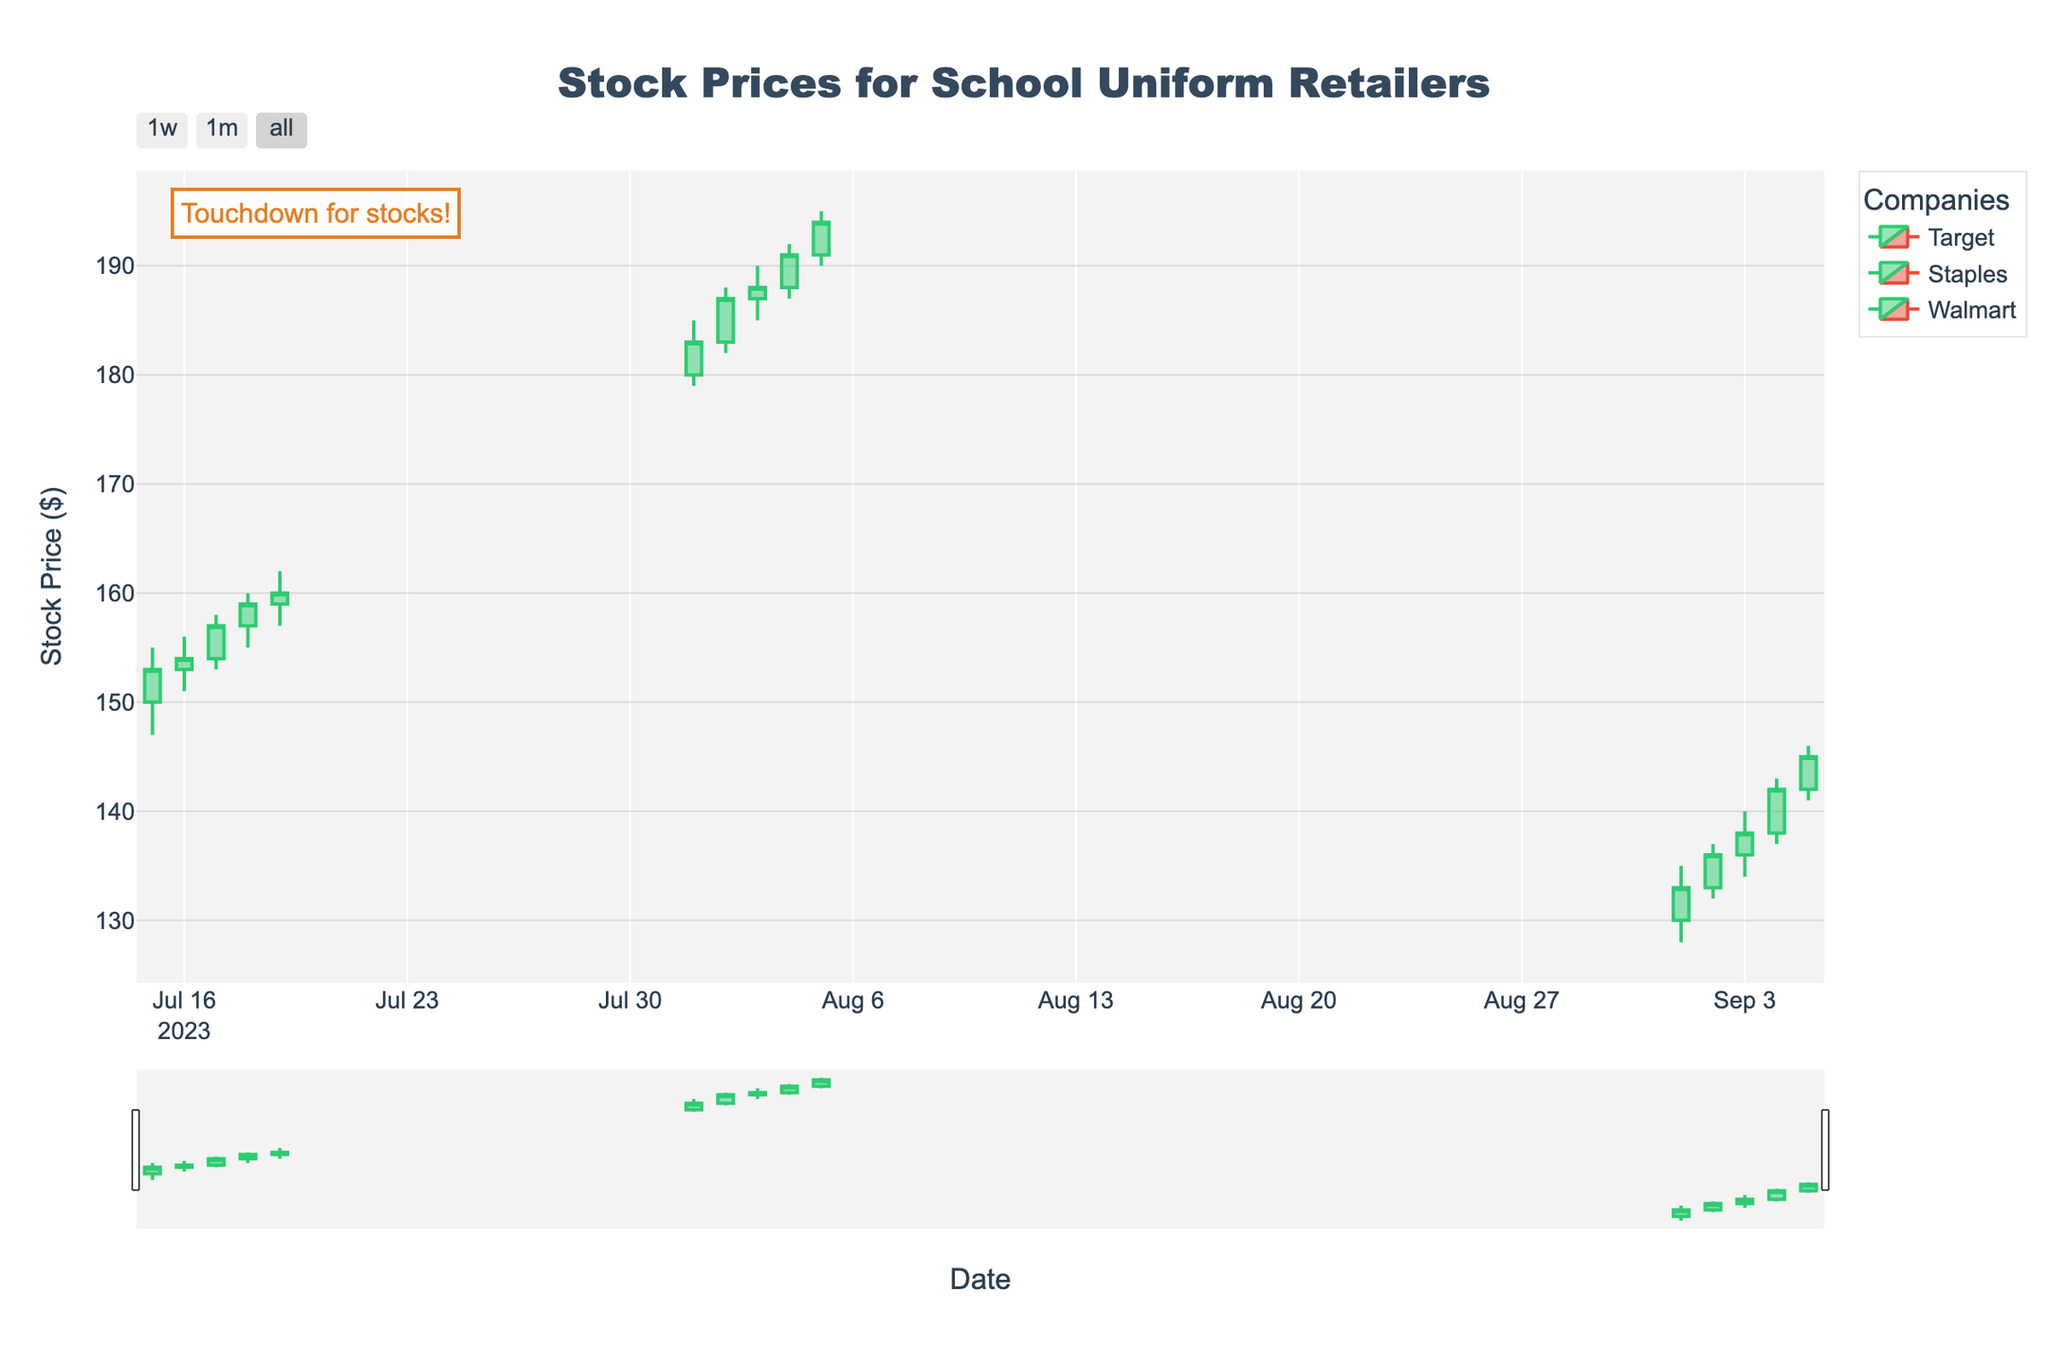What's the title of the figure? The title is usually displayed at the top of the figure. By looking at it, we can identify the title of this specific figure.
Answer: Stock Prices for School Uniform Retailers How many companies are represented in the figure? We can determine the number of companies by observing the legend section, which displays the different companies.
Answer: Three Which company has the highest single-day closing price? By comparing the highest closing price on each company's candlestick, we can see which one is the highest.
Answer: Staples What is the closing price for Walmart on September 05, 2023? Locate Walmart's candlestick for the given date and read the closing price from that candle.
Answer: 145 How did Target’s stock price change from July 15 to July 19, 2023? Observe the opening price on July 15 and the closing price on July 19 to find the difference.
Answer: Increased by 10 How does the trading volume for Staples on August 05 compare with the trading volume for Walmart on September 01? Compare the trading volumes for these two dates from their respective candlesticks.
Answer: Staples had a higher trading volume Did any company's stock price decrease over the period shown? By checking the sequences of candlesticks for each company, we can determine if the closing price declined.
Answer: No What was the trend of Target’s stock price between July 16 and July 19? Analyze the candlesticks from July 16 to July 19 to describe the overall movement of the stock's closing prices.
Answer: Upward trend Identify the date when Target had the highest trading volume shown in the figure. By comparing the trading volumes of Target's candlesticks, we check which date had the highest value.
Answer: July 19, 2023 